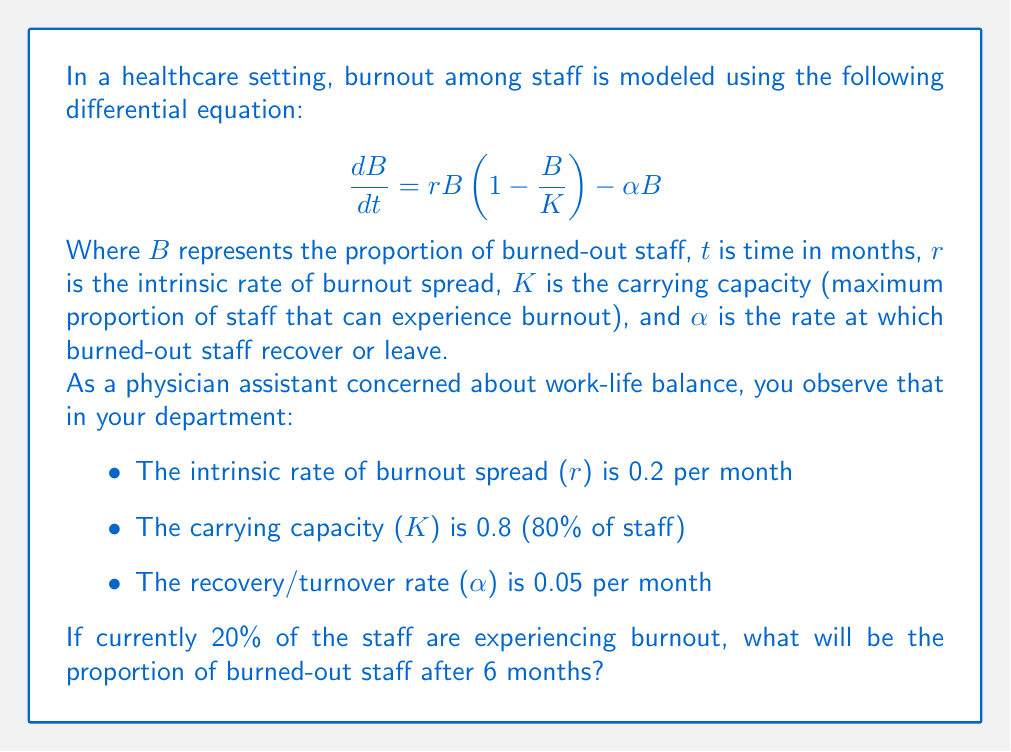Teach me how to tackle this problem. To solve this problem, we need to use the given differential equation and parameters to find the proportion of burned-out staff after 6 months. Let's approach this step-by-step:

1) First, we identify the given parameters:
   $r = 0.2$, $K = 0.8$, $\alpha = 0.05$, $B_0 = 0.2$ (initial burnout proportion), $t = 6$ months

2) The differential equation is:

   $$\frac{dB}{dt} = rB(1-\frac{B}{K}) - \alpha B$$

3) Substituting the values:

   $$\frac{dB}{dt} = 0.2B(1-\frac{B}{0.8}) - 0.05B$$

4) This is a logistic differential equation with an additional linear term. The general solution to this equation is:

   $$B(t) = \frac{K(r-\alpha)}{r + (r-\alpha)e^{-(r-\alpha)t} - \frac{r}{K}B_0}$$

5) Substituting the values:

   $$B(t) = \frac{0.8(0.2-0.05)}{0.2 + (0.2-0.05)e^{-(0.2-0.05)t} - \frac{0.2}{0.8}0.2}$$

6) Simplify:

   $$B(t) = \frac{0.12}{0.2 + 0.15e^{-0.15t} - 0.05}$$

7) Now, we need to find $B(6)$. Substituting $t=6$:

   $$B(6) = \frac{0.12}{0.2 + 0.15e^{-0.15(6)} - 0.05}$$

8) Calculate:

   $$B(6) = \frac{0.12}{0.2 + 0.15(0.4066) - 0.05} = \frac{0.12}{0.2110} = 0.5687$$

Therefore, after 6 months, approximately 56.87% of the staff will be experiencing burnout.
Answer: After 6 months, the proportion of burned-out staff will be approximately 0.5687 or 56.87%. 